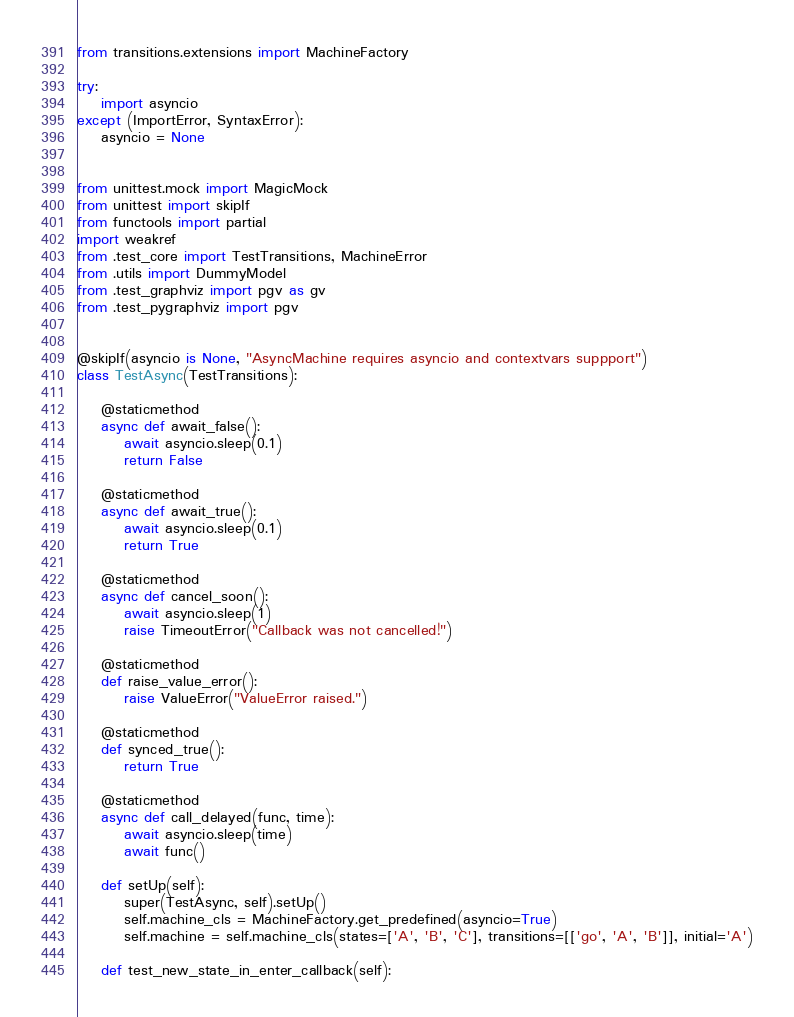Convert code to text. <code><loc_0><loc_0><loc_500><loc_500><_Python_>from transitions.extensions import MachineFactory

try:
    import asyncio
except (ImportError, SyntaxError):
    asyncio = None


from unittest.mock import MagicMock
from unittest import skipIf
from functools import partial
import weakref
from .test_core import TestTransitions, MachineError
from .utils import DummyModel
from .test_graphviz import pgv as gv
from .test_pygraphviz import pgv


@skipIf(asyncio is None, "AsyncMachine requires asyncio and contextvars suppport")
class TestAsync(TestTransitions):

    @staticmethod
    async def await_false():
        await asyncio.sleep(0.1)
        return False

    @staticmethod
    async def await_true():
        await asyncio.sleep(0.1)
        return True

    @staticmethod
    async def cancel_soon():
        await asyncio.sleep(1)
        raise TimeoutError("Callback was not cancelled!")

    @staticmethod
    def raise_value_error():
        raise ValueError("ValueError raised.")

    @staticmethod
    def synced_true():
        return True

    @staticmethod
    async def call_delayed(func, time):
        await asyncio.sleep(time)
        await func()

    def setUp(self):
        super(TestAsync, self).setUp()
        self.machine_cls = MachineFactory.get_predefined(asyncio=True)
        self.machine = self.machine_cls(states=['A', 'B', 'C'], transitions=[['go', 'A', 'B']], initial='A')

    def test_new_state_in_enter_callback(self):</code> 